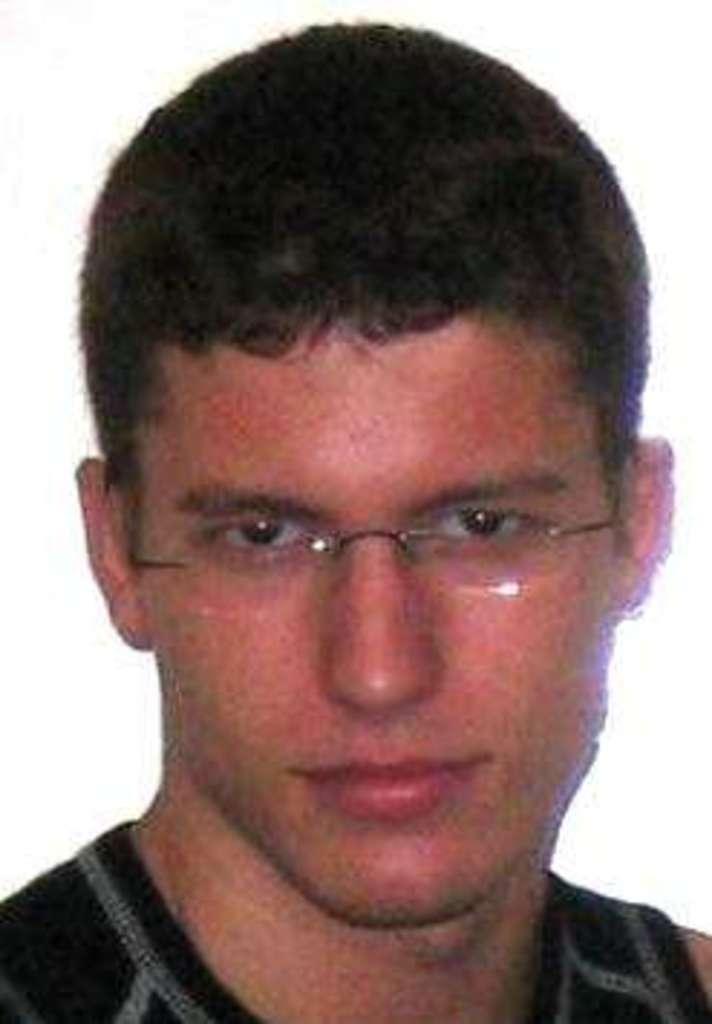How would you summarize this image in a sentence or two? In this image, I can see a man with spectacles and clothes. There is a white background. 